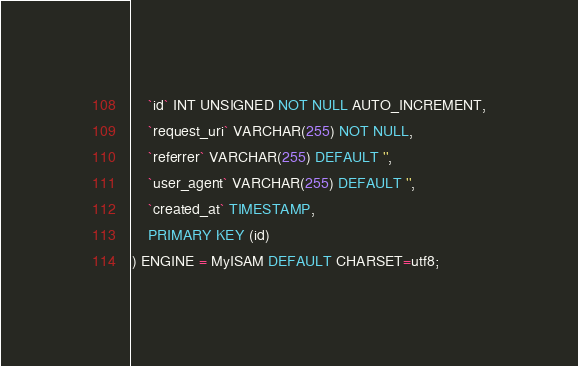Convert code to text. <code><loc_0><loc_0><loc_500><loc_500><_SQL_>    `id` INT UNSIGNED NOT NULL AUTO_INCREMENT,
    `request_uri` VARCHAR(255) NOT NULL,
    `referrer` VARCHAR(255) DEFAULT '',
    `user_agent` VARCHAR(255) DEFAULT '',
    `created_at` TIMESTAMP,
    PRIMARY KEY (id)
) ENGINE = MyISAM DEFAULT CHARSET=utf8;</code> 